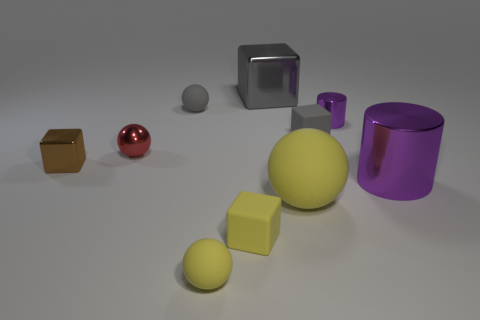There is a tiny ball that is both in front of the small gray matte sphere and to the right of the tiny red object; what material is it?
Your answer should be compact. Rubber. Does the brown metal thing have the same shape as the small purple thing?
Give a very brief answer. No. Is there any other thing that is the same size as the gray sphere?
Your response must be concise. Yes. What number of yellow spheres are left of the big cube?
Give a very brief answer. 1. There is a metal block that is right of the red ball; is its size the same as the red object?
Make the answer very short. No. The other metal thing that is the same shape as the small purple object is what color?
Offer a very short reply. Purple. Is there anything else that has the same shape as the brown object?
Provide a short and direct response. Yes. There is a tiny metal object behind the red sphere; what is its shape?
Keep it short and to the point. Cylinder. How many large matte objects are the same shape as the tiny red metallic thing?
Offer a very short reply. 1. There is a shiny cube behind the red metallic object; is it the same color as the small metallic thing to the right of the small gray rubber ball?
Your answer should be very brief. No. 